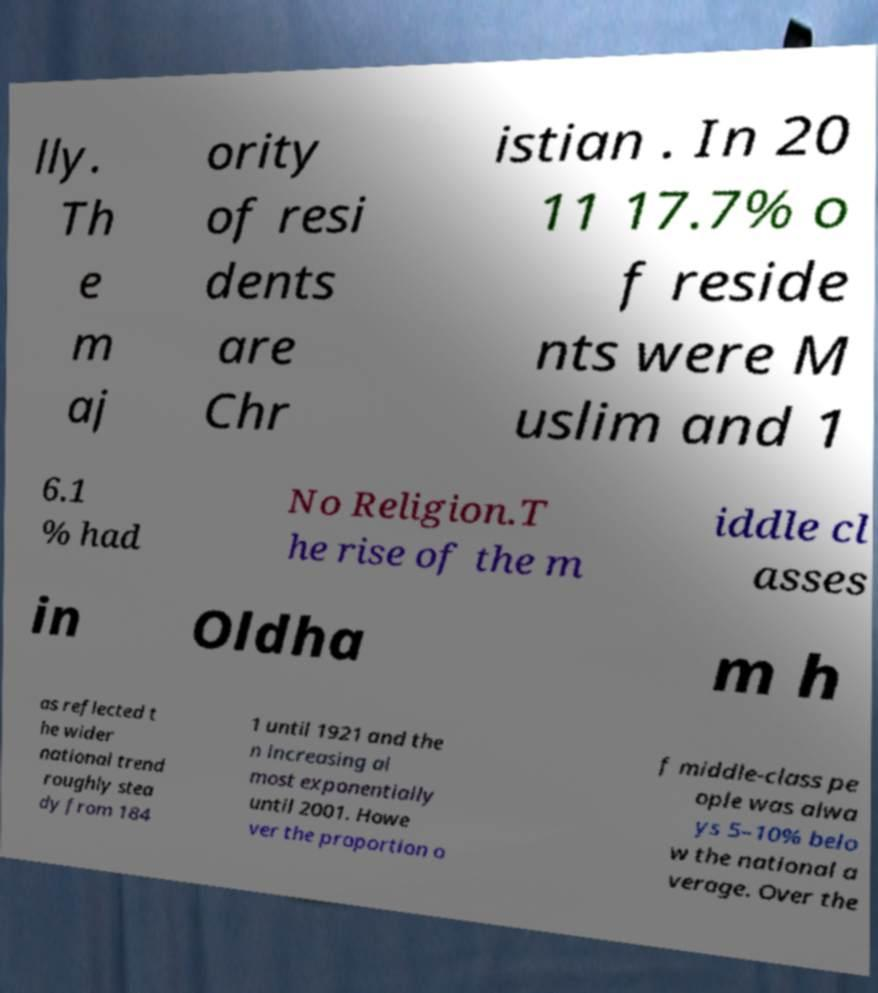I need the written content from this picture converted into text. Can you do that? lly. Th e m aj ority of resi dents are Chr istian . In 20 11 17.7% o f reside nts were M uslim and 1 6.1 % had No Religion.T he rise of the m iddle cl asses in Oldha m h as reflected t he wider national trend roughly stea dy from 184 1 until 1921 and the n increasing al most exponentially until 2001. Howe ver the proportion o f middle-class pe ople was alwa ys 5–10% belo w the national a verage. Over the 